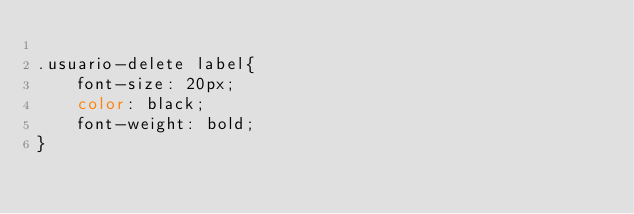Convert code to text. <code><loc_0><loc_0><loc_500><loc_500><_CSS_>
.usuario-delete label{
    font-size: 20px;
    color: black;
    font-weight: bold;
}</code> 